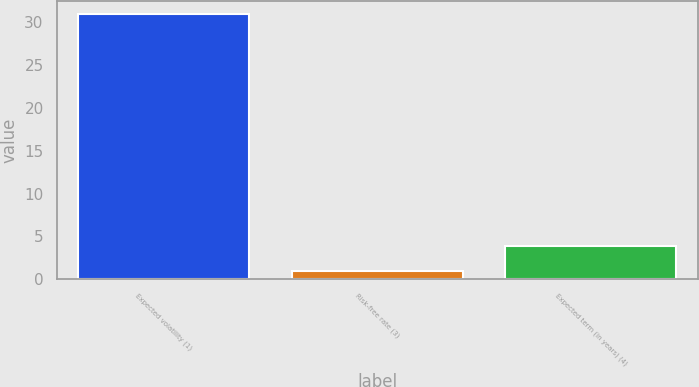Convert chart to OTSL. <chart><loc_0><loc_0><loc_500><loc_500><bar_chart><fcel>Expected volatility (1)<fcel>Risk-free rate (3)<fcel>Expected term (in years) (4)<nl><fcel>31<fcel>0.92<fcel>3.93<nl></chart> 